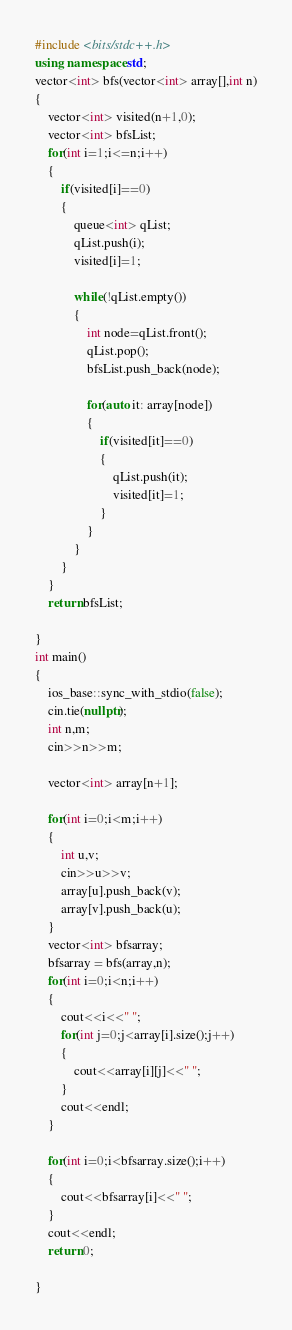Convert code to text. <code><loc_0><loc_0><loc_500><loc_500><_C++_>#include <bits/stdc++.h>
using namespace std;
vector<int> bfs(vector<int> array[],int n)
{
    vector<int> visited(n+1,0);
    vector<int> bfsList;
    for(int i=1;i<=n;i++)
    {
        if(visited[i]==0)
        {
            queue<int> qList;
            qList.push(i);
            visited[i]=1;

            while(!qList.empty())
            {
                int node=qList.front();
                qList.pop();
                bfsList.push_back(node);

                for(auto it: array[node])
                {
                    if(visited[it]==0)
                    {
                        qList.push(it);
                        visited[it]=1;
                    }
                }
            }
        }
    }
    return bfsList;

}
int main()
{  
    ios_base::sync_with_stdio(false);
    cin.tie(nullptr);
    int n,m;
    cin>>n>>m;

    vector<int> array[n+1];

    for(int i=0;i<m;i++)
    {
        int u,v;
        cin>>u>>v;
        array[u].push_back(v);
        array[v].push_back(u);
    }
    vector<int> bfsarray;
    bfsarray = bfs(array,n);
    for(int i=0;i<n;i++)
    {
        cout<<i<<" ";
        for(int j=0;j<array[i].size();j++)
        {
            cout<<array[i][j]<<" ";
        }
        cout<<endl;
    }

    for(int i=0;i<bfsarray.size();i++)
    {
        cout<<bfsarray[i]<<" ";
    }
    cout<<endl;
    return 0;

}
</code> 